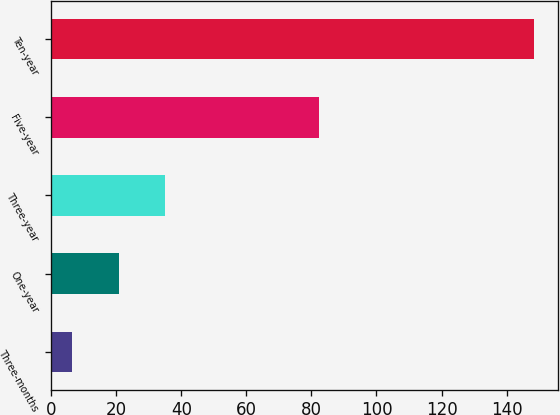<chart> <loc_0><loc_0><loc_500><loc_500><bar_chart><fcel>Three-months<fcel>One-year<fcel>Three-year<fcel>Five-year<fcel>Ten-year<nl><fcel>6.5<fcel>20.68<fcel>34.86<fcel>82.4<fcel>148.3<nl></chart> 